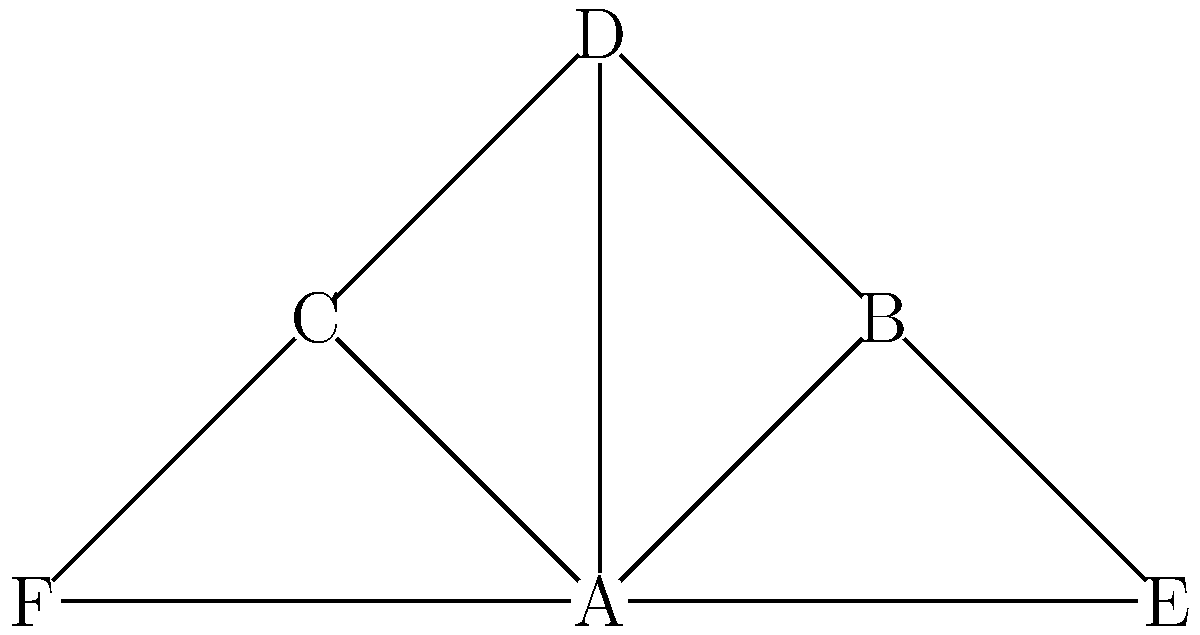In the network diagram of political connections in Prince George's County, node A represents a key community organizer. If this organizer were to step down, which node's removal would cause the greatest fragmentation in the network, potentially disrupting the flow of information and resources? To determine which node's removal would cause the greatest fragmentation, we need to analyze the connectivity of each node:

1. Node A: Connected to B, C, D, and E. Removing A would disconnect these nodes but not completely fragment the network.

2. Node B: Connected to A, D, and E. Removing B would not significantly fragment the network.

3. Node C: Connected to A, D, and F. Removing C would not significantly fragment the network.

4. Node D: Connected to A, B, and C. Removing D would not significantly fragment the network.

5. Node E: Connected to A, B, and F. Removing E would not significantly fragment the network.

6. Node F: Connected to C and E. Removing F would only disconnect itself from the network.

The node that would cause the greatest fragmentation is A because:
1. It has the highest degree (connected to 4 other nodes).
2. It serves as a central hub connecting all other nodes.
3. Its removal would create multiple disconnected components (B-D-E and C-F).

Therefore, removing node A would cause the greatest disruption to the flow of information and resources in the network.
Answer: Node A 